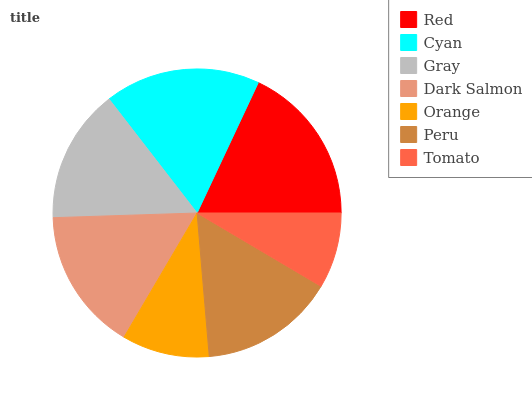Is Tomato the minimum?
Answer yes or no. Yes. Is Red the maximum?
Answer yes or no. Yes. Is Cyan the minimum?
Answer yes or no. No. Is Cyan the maximum?
Answer yes or no. No. Is Red greater than Cyan?
Answer yes or no. Yes. Is Cyan less than Red?
Answer yes or no. Yes. Is Cyan greater than Red?
Answer yes or no. No. Is Red less than Cyan?
Answer yes or no. No. Is Peru the high median?
Answer yes or no. Yes. Is Peru the low median?
Answer yes or no. Yes. Is Dark Salmon the high median?
Answer yes or no. No. Is Red the low median?
Answer yes or no. No. 